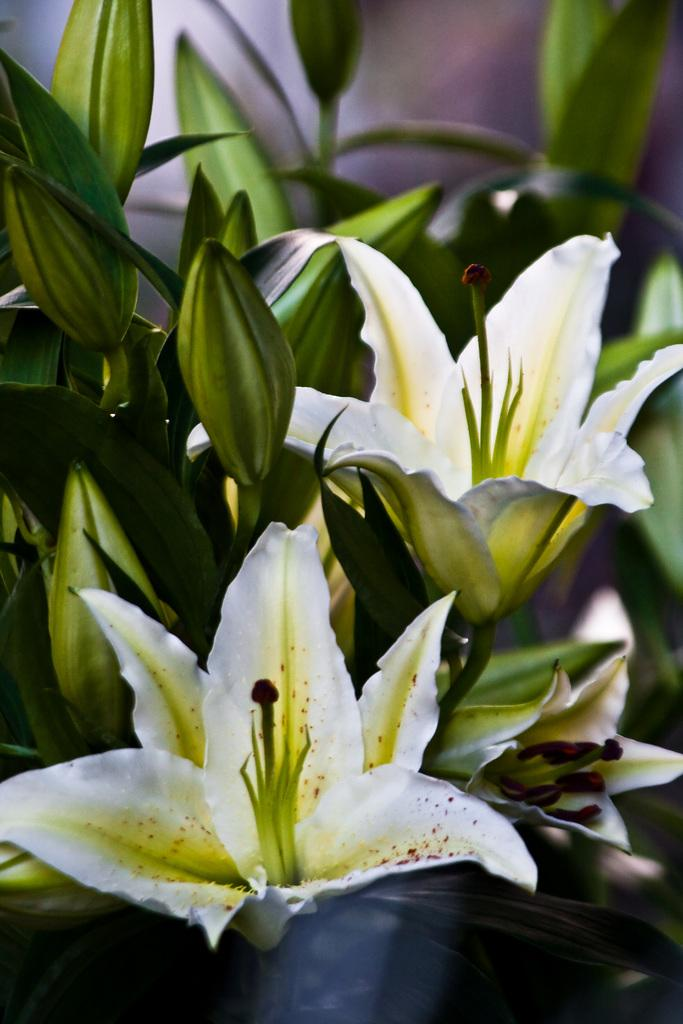What type of living organisms can be seen in the image? There are flowers in the image. What colors are the flowers? The flowers are white, yellow, and green in color. Where are the flowers located? The flowers are on a plant. What is the color of the plant? The plant is green in color. How would you describe the background of the image? The background of the image is blurry. What type of soup is being served in the image? There is no soup present in the image; it features flowers on a plant. Can you tell me how many eggs are in the eggnog in the image? There is no eggnog or eggs present in the image. 